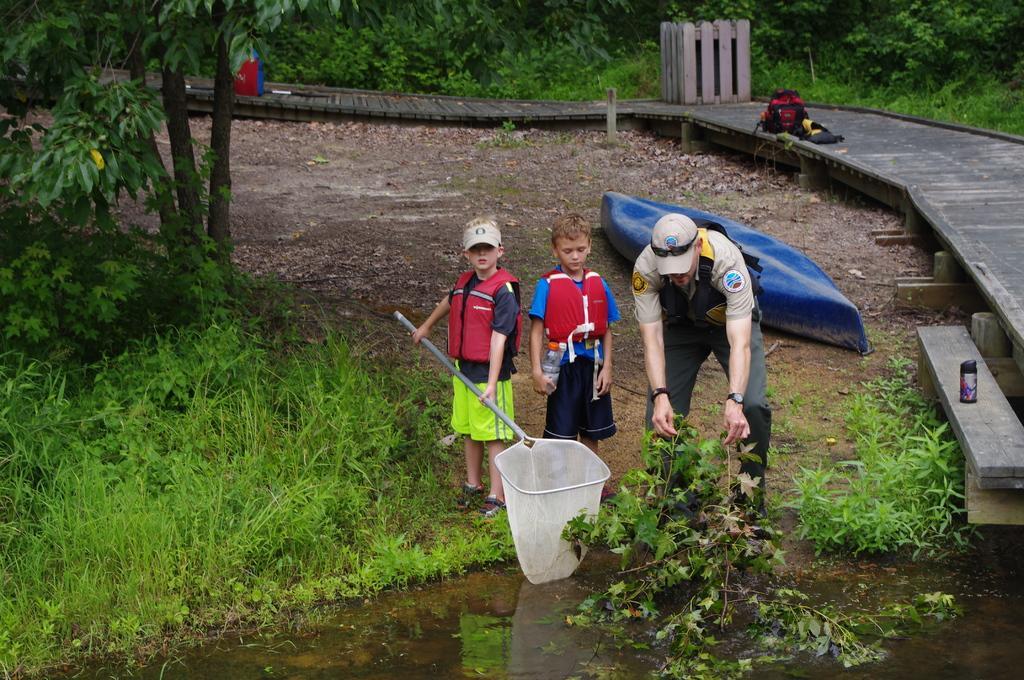Could you give a brief overview of what you see in this image? In this image there is man and two kids one of the kid is holding a mesh in his hands and man is holding plants there is pond on the right side there is a bridge, on the left side there is grass, tree, in the background there are trees, behind the man there is a boat. 